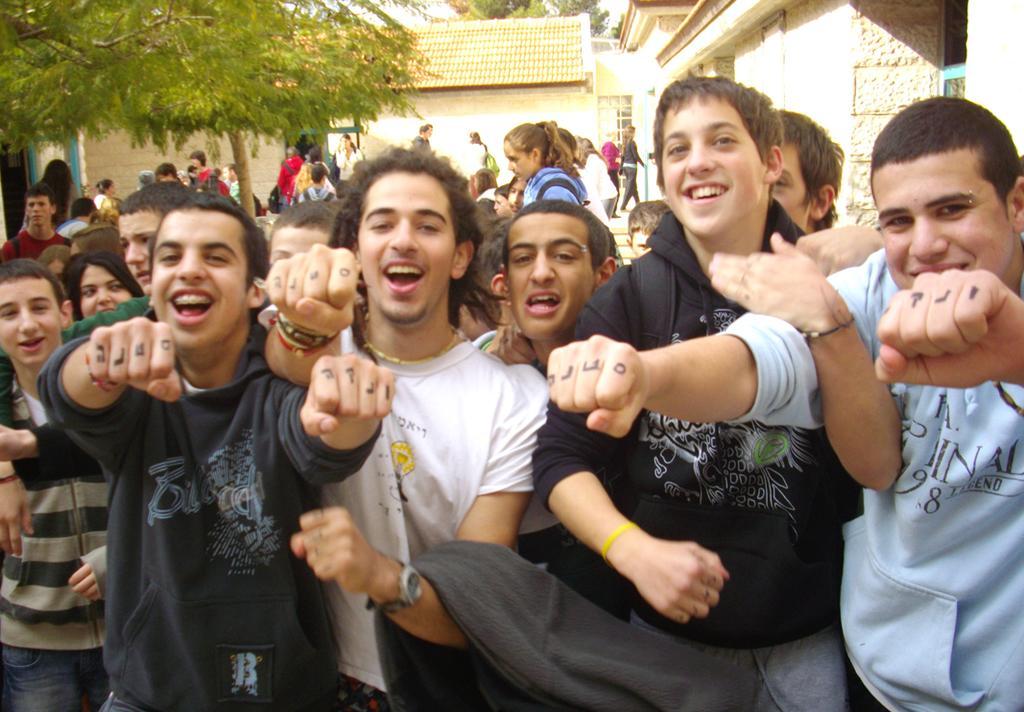Describe this image in one or two sentences. In this image I can see group of people standing. Background I can see few buildings, and trees in green color. 